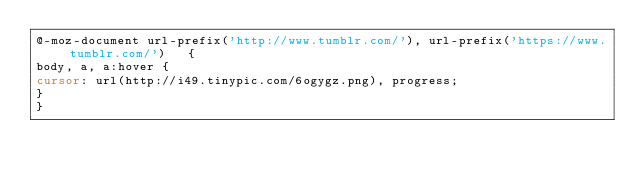Convert code to text. <code><loc_0><loc_0><loc_500><loc_500><_CSS_>@-moz-document url-prefix('http://www.tumblr.com/'), url-prefix('https://www.tumblr.com/')   {
body, a, a:hover {
cursor: url(http://i49.tinypic.com/6ogygz.png), progress;
}
}</code> 